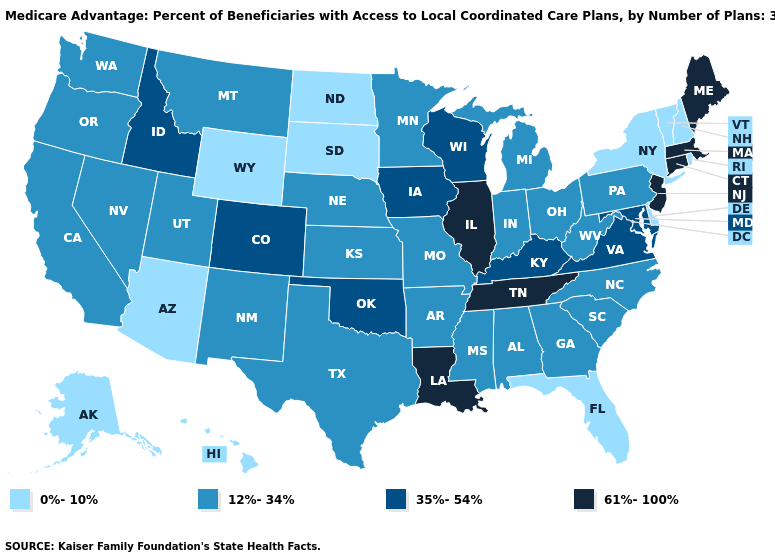What is the lowest value in the West?
Give a very brief answer. 0%-10%. What is the highest value in the USA?
Give a very brief answer. 61%-100%. Does the map have missing data?
Short answer required. No. Among the states that border Indiana , which have the highest value?
Concise answer only. Illinois. What is the lowest value in states that border Connecticut?
Give a very brief answer. 0%-10%. Does the first symbol in the legend represent the smallest category?
Concise answer only. Yes. Name the states that have a value in the range 0%-10%?
Short answer required. Alaska, Arizona, Delaware, Florida, Hawaii, North Dakota, New Hampshire, New York, Rhode Island, South Dakota, Vermont, Wyoming. What is the value of Iowa?
Answer briefly. 35%-54%. What is the value of Pennsylvania?
Short answer required. 12%-34%. What is the highest value in states that border New Jersey?
Be succinct. 12%-34%. Does Connecticut have the same value as Tennessee?
Keep it brief. Yes. Name the states that have a value in the range 0%-10%?
Be succinct. Alaska, Arizona, Delaware, Florida, Hawaii, North Dakota, New Hampshire, New York, Rhode Island, South Dakota, Vermont, Wyoming. Does South Carolina have the highest value in the USA?
Be succinct. No. Name the states that have a value in the range 35%-54%?
Short answer required. Colorado, Iowa, Idaho, Kentucky, Maryland, Oklahoma, Virginia, Wisconsin. 